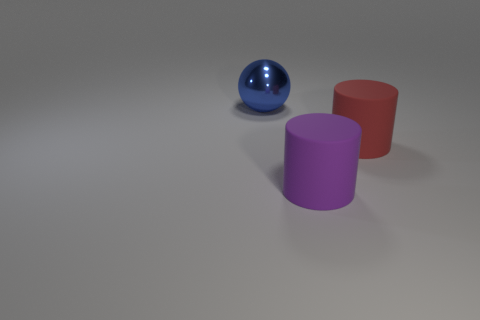Add 3 red objects. How many objects exist? 6 Subtract all cylinders. How many objects are left? 1 Add 1 big matte things. How many big matte things are left? 3 Add 1 large brown shiny cubes. How many large brown shiny cubes exist? 1 Subtract 0 yellow blocks. How many objects are left? 3 Subtract all green metal balls. Subtract all red cylinders. How many objects are left? 2 